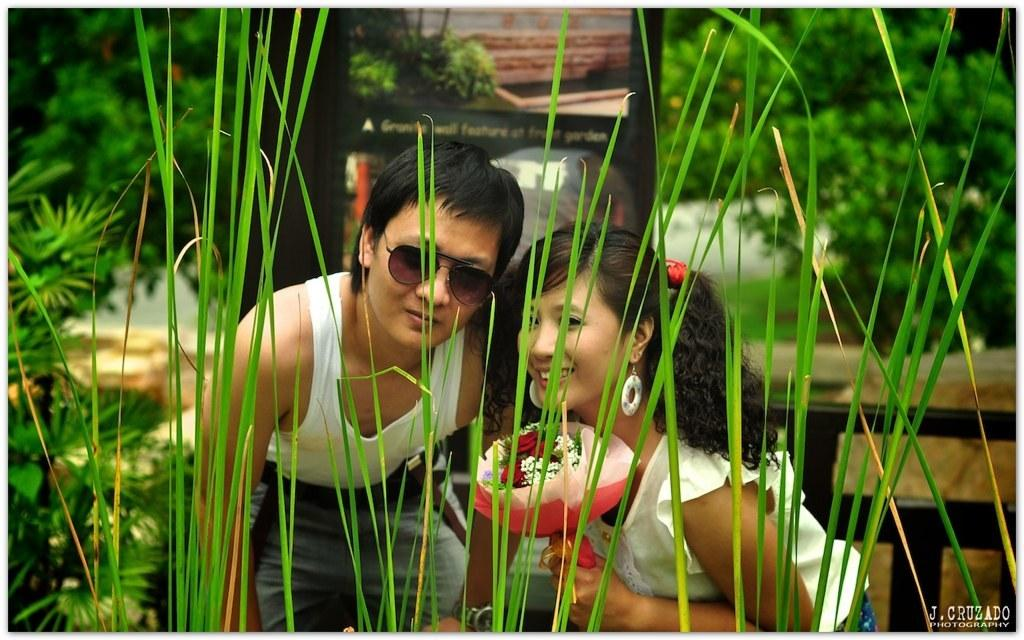Who is present in the image? There is a couple in the image. What is the facial expression of the man in the couple? The man in the couple is smiling. What type of vegetation is in front of the couple? There is grass and plants in front of the couple. What can be seen behind the couple? There is a wooden structure and trees behind the couple. What type of seed is the couple planting in the image? There is no seed present in the image, nor is the couple shown planting anything. 